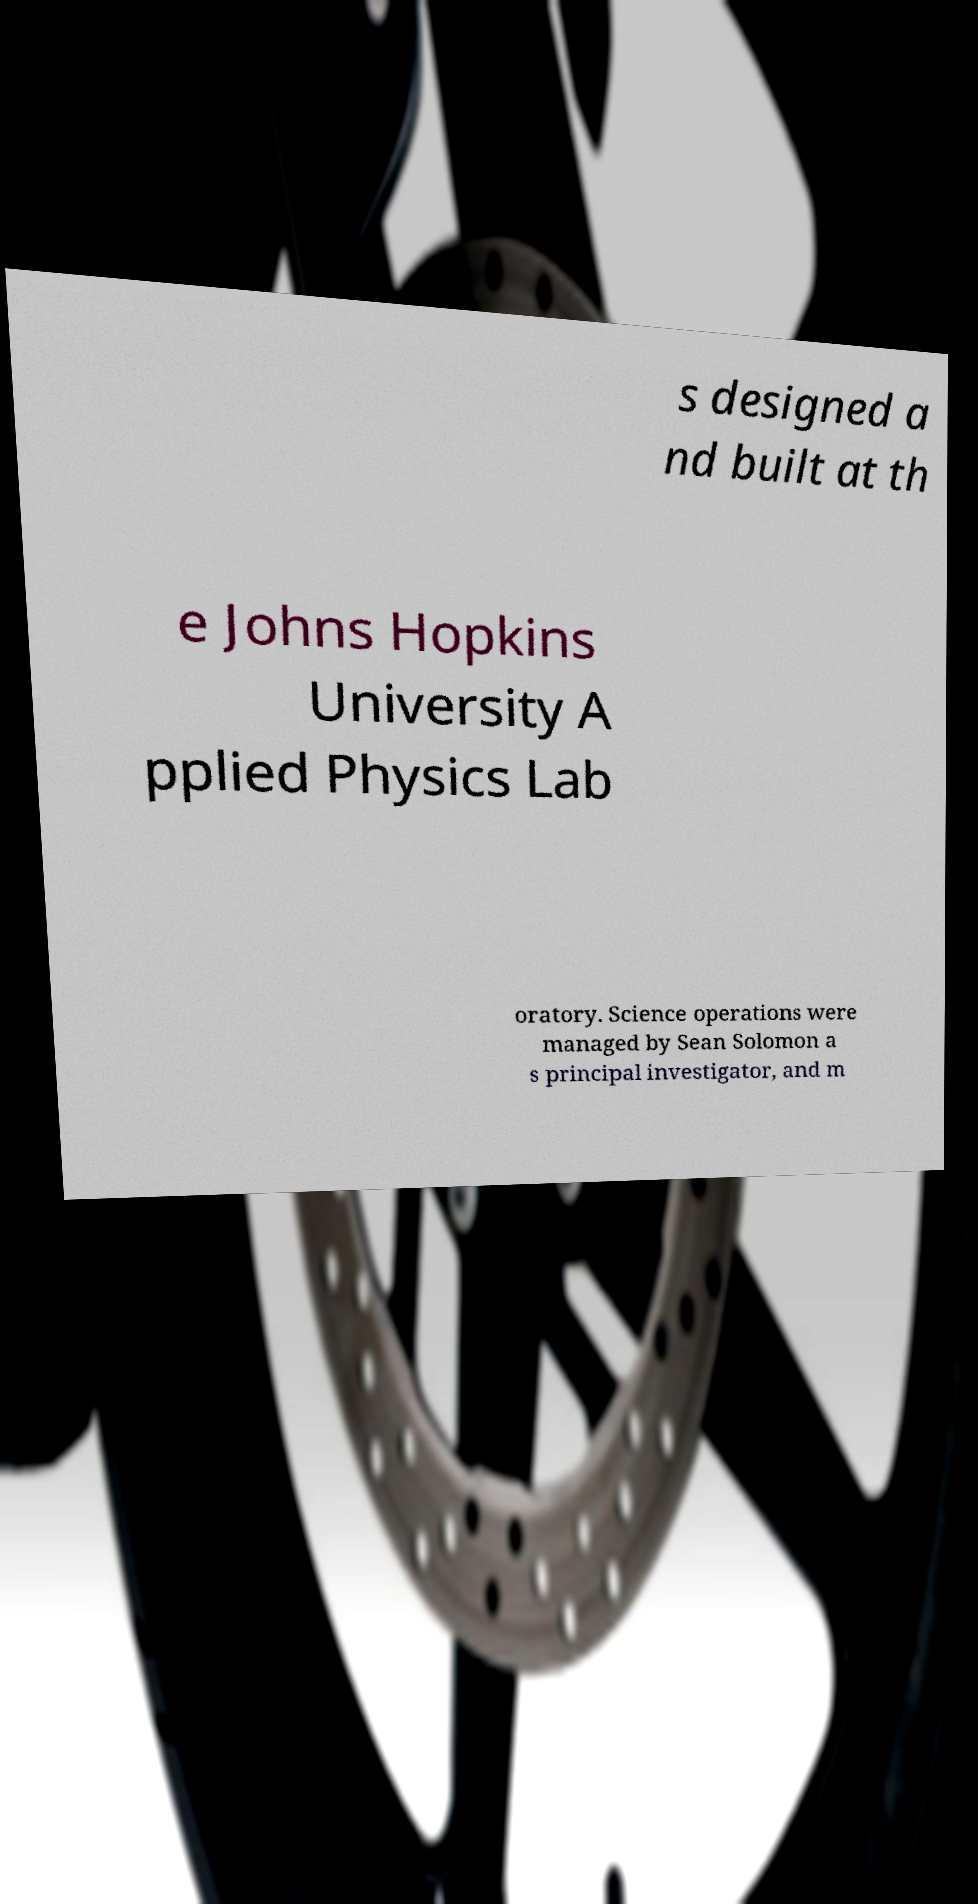Could you extract and type out the text from this image? s designed a nd built at th e Johns Hopkins University A pplied Physics Lab oratory. Science operations were managed by Sean Solomon a s principal investigator, and m 